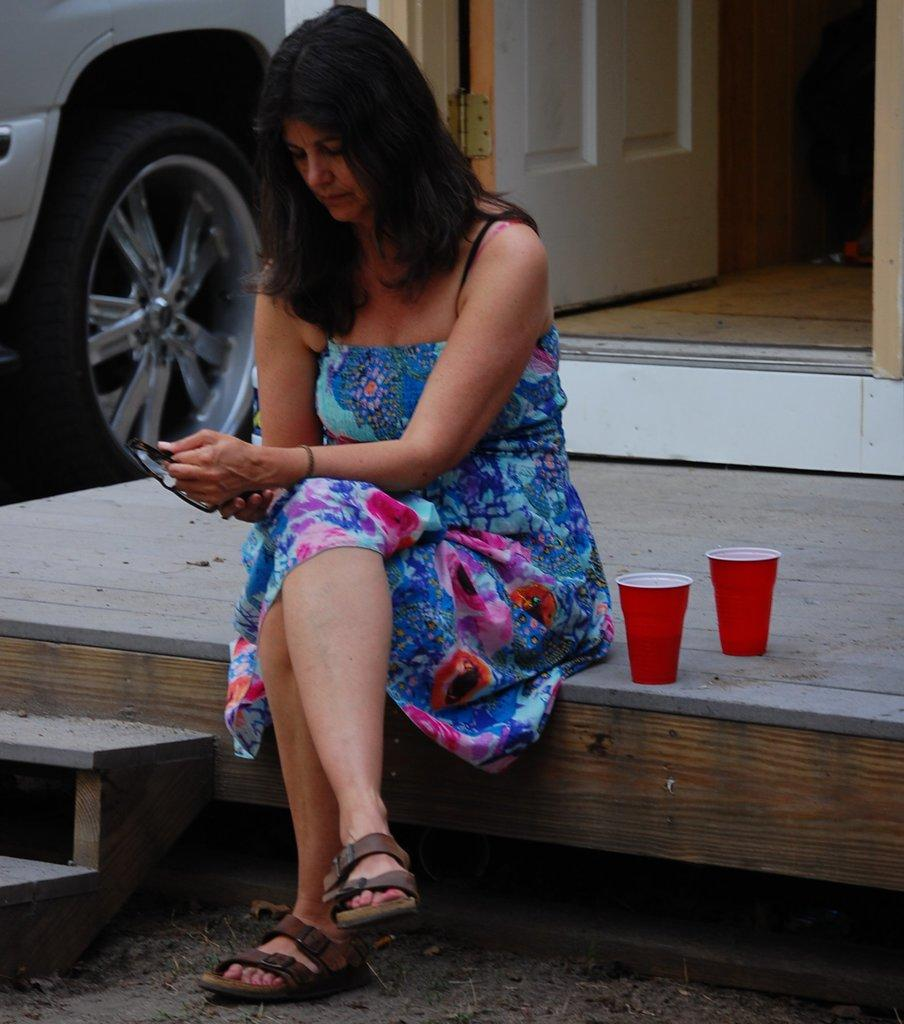What is the lady doing in the image? The lady is sitting on the wooden floor. What is the lady holding in the image? The lady is holding goggles. What objects are beside the lady? There are two glasses beside the lady. What can be seen in the image related to transportation? There is a vehicle in the image. What architectural feature is present in the image? There is a door in the image. What is a feature of the location that the lady is in? There are steps in the image. What time of day is it in the image, considering the afternoon? The time of day cannot be determined from the image, as there is no reference to the time or the afternoon. 